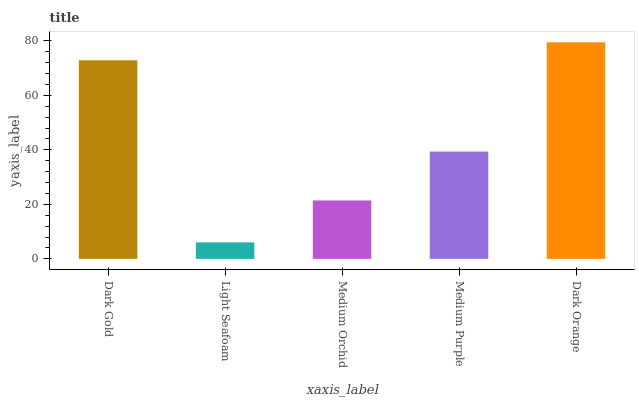Is Light Seafoam the minimum?
Answer yes or no. Yes. Is Dark Orange the maximum?
Answer yes or no. Yes. Is Medium Orchid the minimum?
Answer yes or no. No. Is Medium Orchid the maximum?
Answer yes or no. No. Is Medium Orchid greater than Light Seafoam?
Answer yes or no. Yes. Is Light Seafoam less than Medium Orchid?
Answer yes or no. Yes. Is Light Seafoam greater than Medium Orchid?
Answer yes or no. No. Is Medium Orchid less than Light Seafoam?
Answer yes or no. No. Is Medium Purple the high median?
Answer yes or no. Yes. Is Medium Purple the low median?
Answer yes or no. Yes. Is Medium Orchid the high median?
Answer yes or no. No. Is Dark Gold the low median?
Answer yes or no. No. 